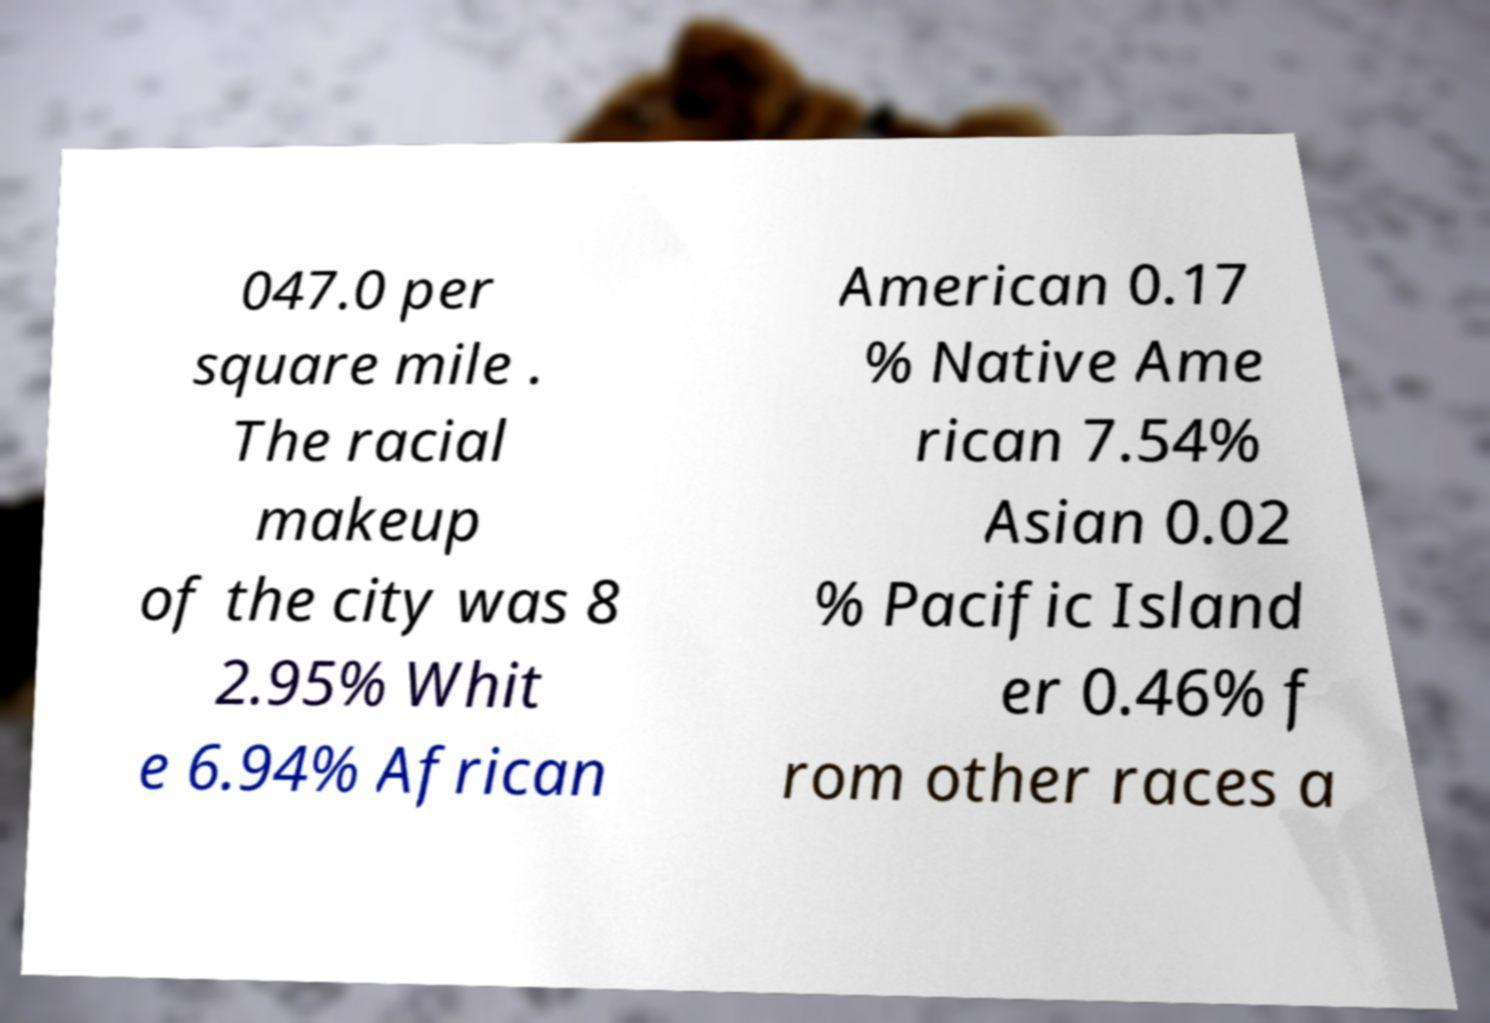For documentation purposes, I need the text within this image transcribed. Could you provide that? 047.0 per square mile . The racial makeup of the city was 8 2.95% Whit e 6.94% African American 0.17 % Native Ame rican 7.54% Asian 0.02 % Pacific Island er 0.46% f rom other races a 